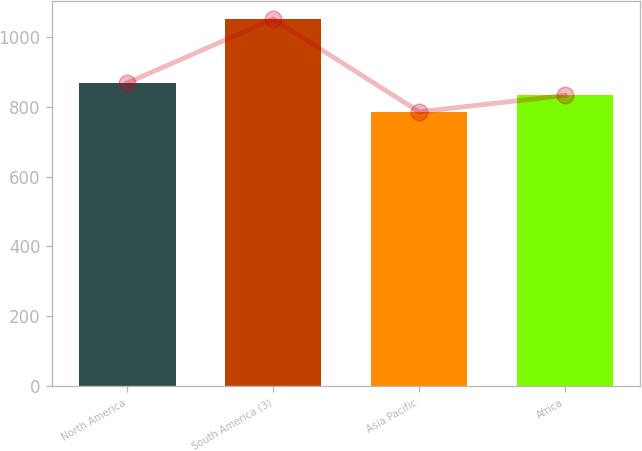<chart> <loc_0><loc_0><loc_500><loc_500><bar_chart><fcel>North America<fcel>South America (3)<fcel>Asia Pacific<fcel>Africa<nl><fcel>869<fcel>1052<fcel>786<fcel>833<nl></chart> 